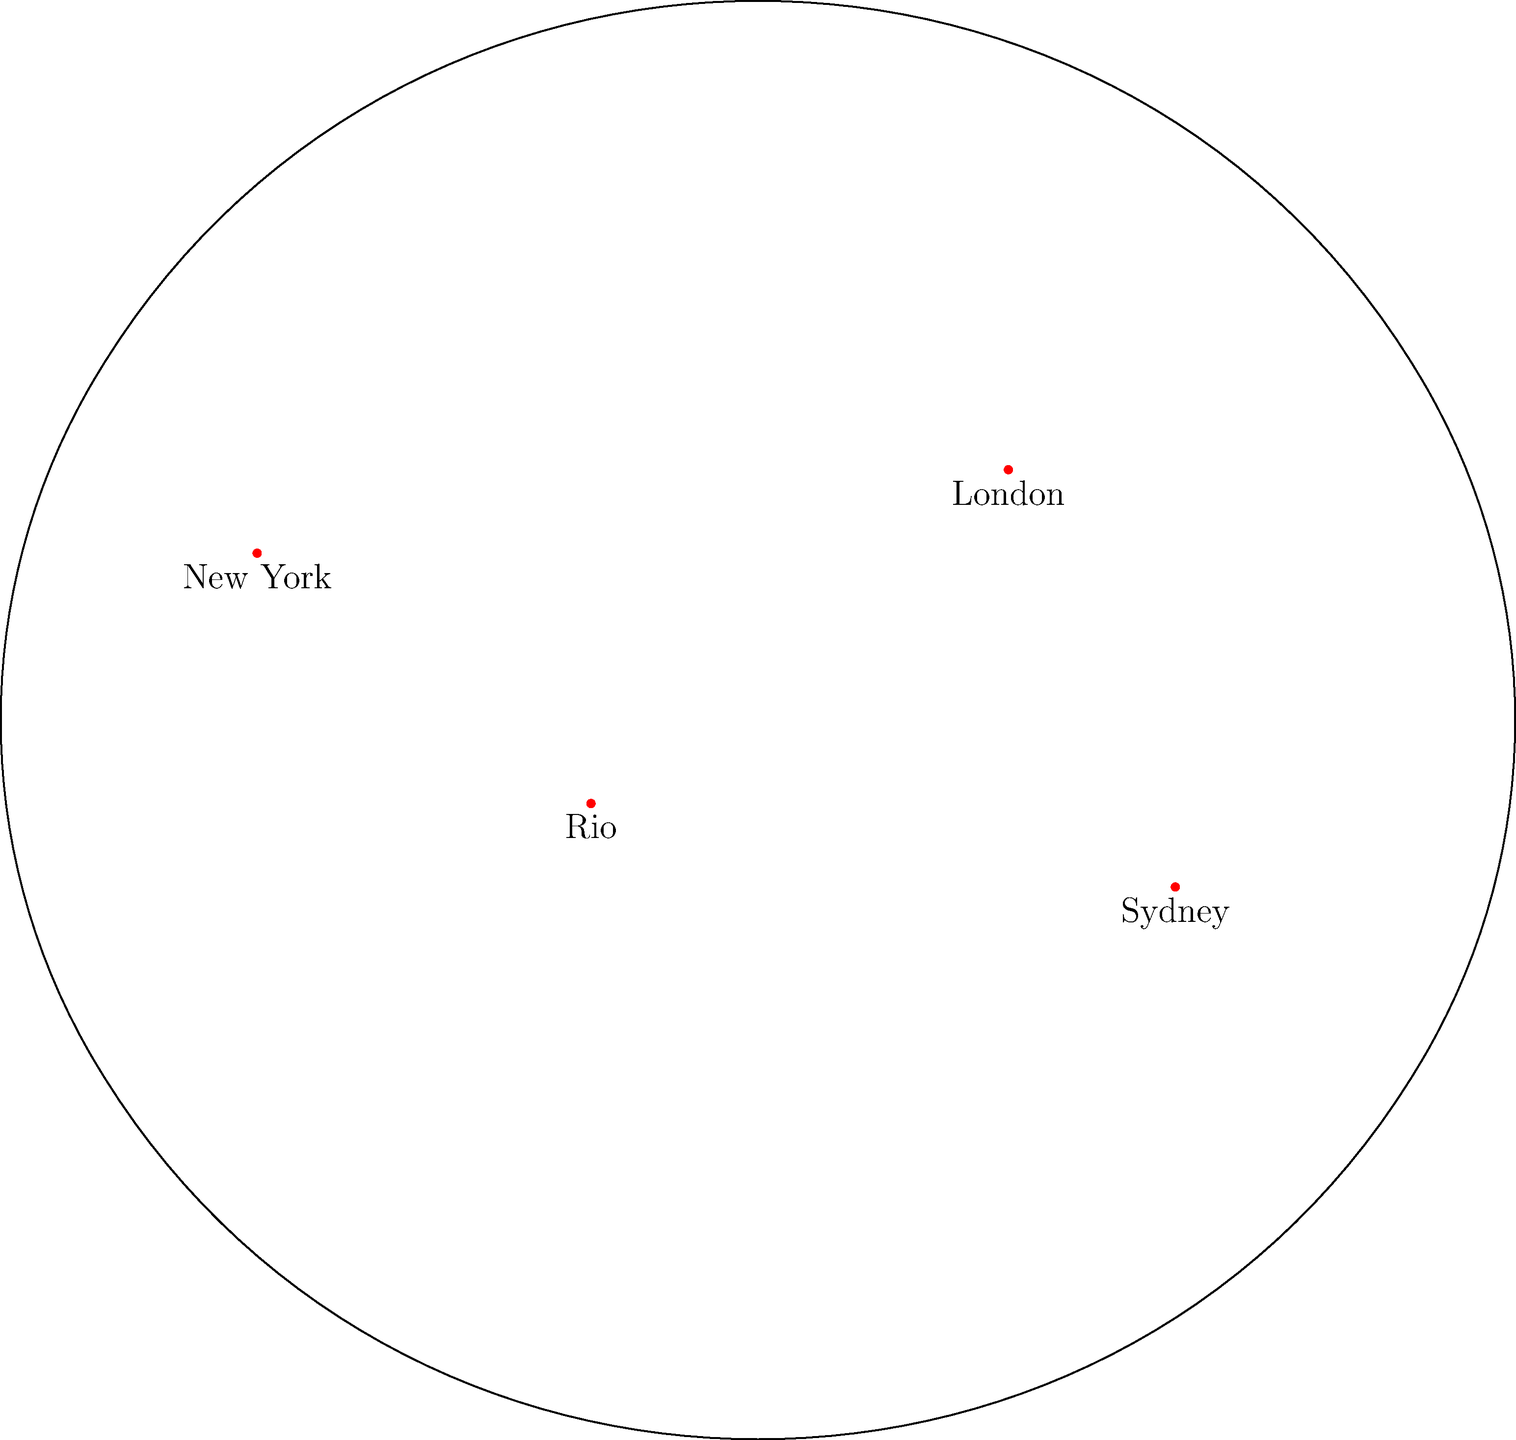In the sportscaster's memoir, four major cities are frequently mentioned as significant locations in their career. Based on the world map provided, which city is located furthest north? To determine which city is located furthest north, we need to compare the vertical positions (y-coordinates) of the points on the map:

1. New York: y ≈ 2
2. Rio: y ≈ -1
3. London: y ≈ 3
4. Sydney: y ≈ -2

The city with the highest y-coordinate will be the furthest north. Comparing the values:

- Sydney and Rio have negative y-values, so they are in the southern hemisphere.
- New York has a positive y-value (2), placing it in the northern hemisphere.
- London has the highest y-value (3), making it the furthest north of all the cities mentioned.

Therefore, London is located furthest north among the four cities mentioned in the sportscaster's memoir.
Answer: London 